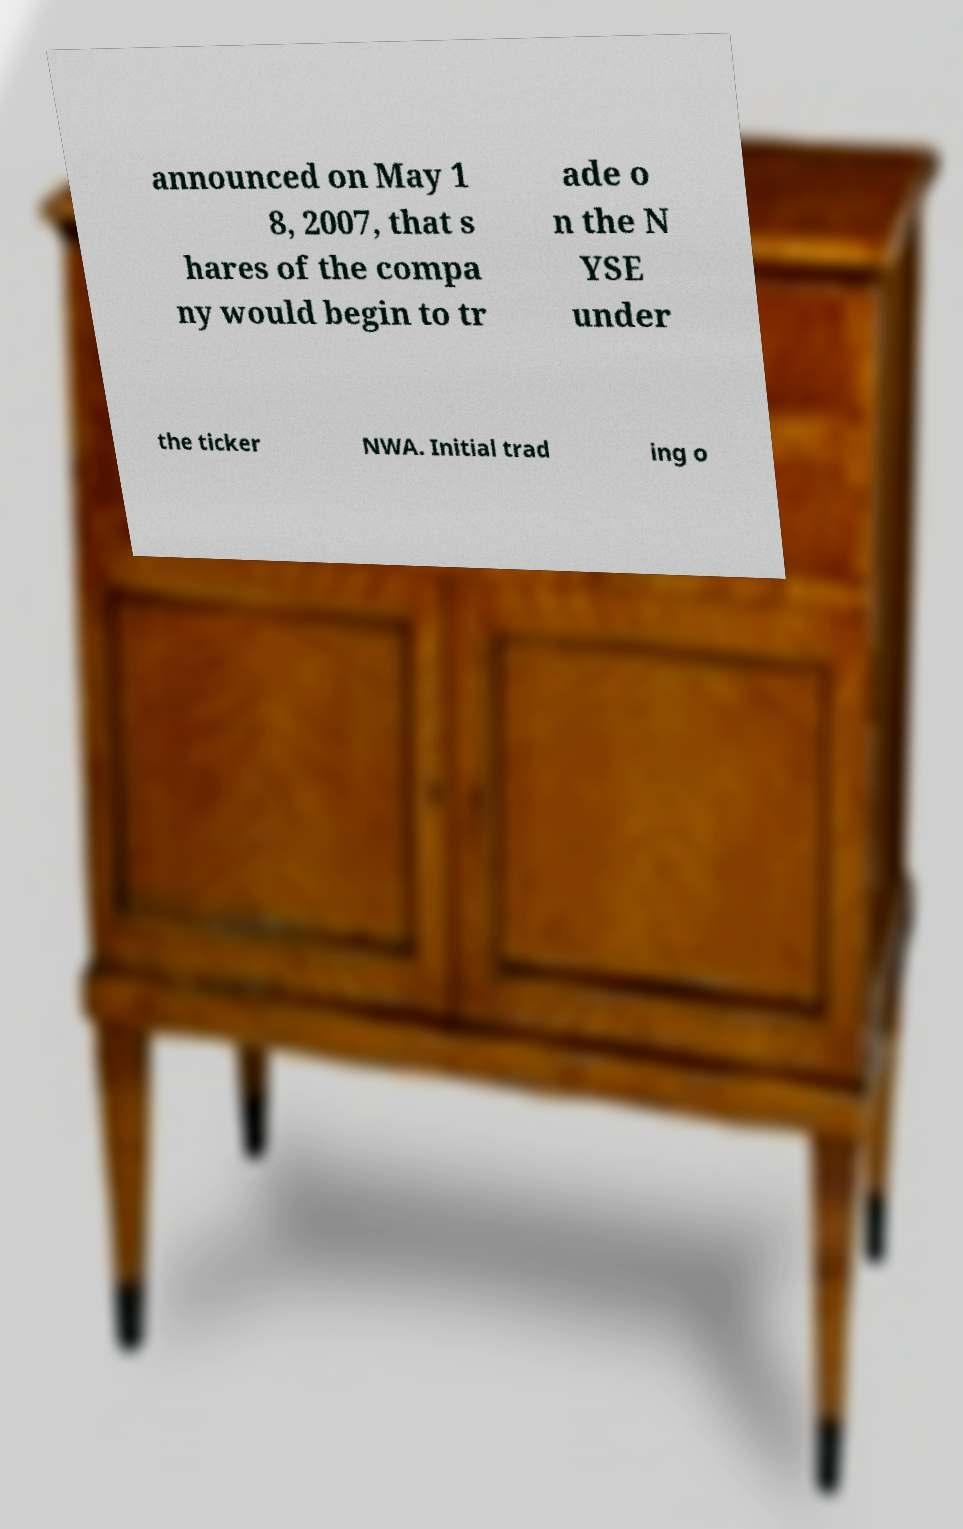Please read and relay the text visible in this image. What does it say? announced on May 1 8, 2007, that s hares of the compa ny would begin to tr ade o n the N YSE under the ticker NWA. Initial trad ing o 